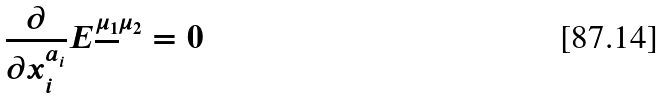Convert formula to latex. <formula><loc_0><loc_0><loc_500><loc_500>\frac { \partial } { \partial x ^ { a _ { i } } _ { i } } E ^ { \underline { \mu _ { 1 } } \mu _ { 2 } } = 0</formula> 